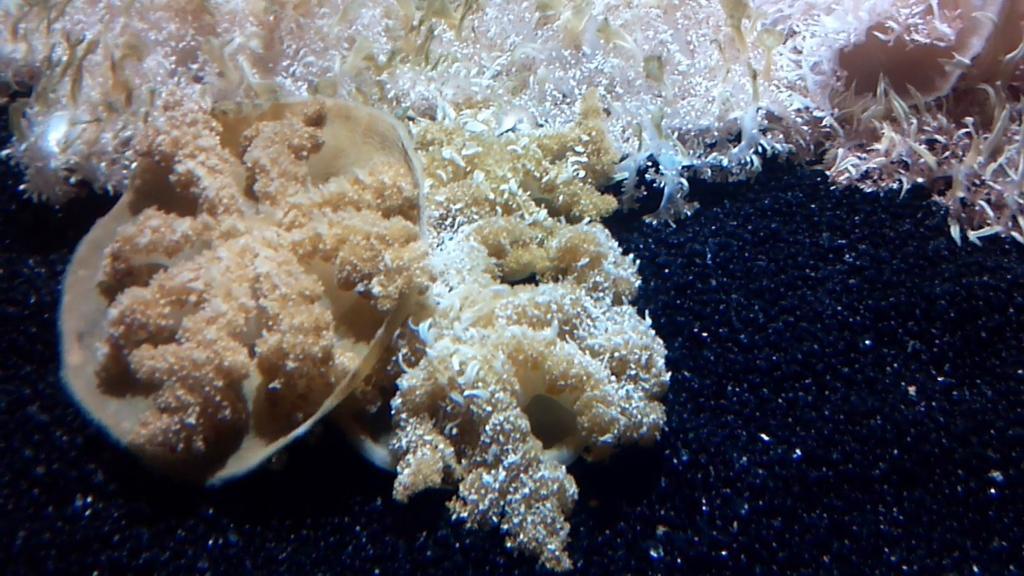Please provide a concise description of this image. It looks like fungus and there is shell. 